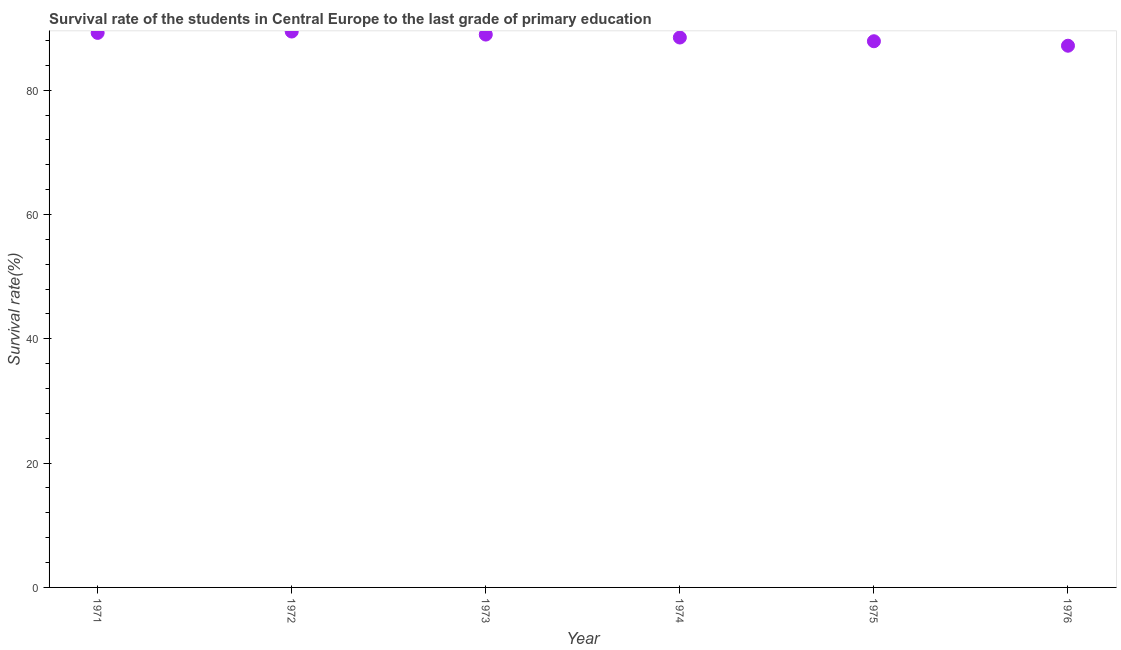What is the survival rate in primary education in 1971?
Provide a short and direct response. 89.22. Across all years, what is the maximum survival rate in primary education?
Ensure brevity in your answer.  89.44. Across all years, what is the minimum survival rate in primary education?
Ensure brevity in your answer.  87.16. In which year was the survival rate in primary education minimum?
Your answer should be compact. 1976. What is the sum of the survival rate in primary education?
Provide a short and direct response. 531.13. What is the difference between the survival rate in primary education in 1973 and 1974?
Provide a succinct answer. 0.47. What is the average survival rate in primary education per year?
Provide a short and direct response. 88.52. What is the median survival rate in primary education?
Your answer should be compact. 88.71. In how many years, is the survival rate in primary education greater than 8 %?
Provide a succinct answer. 6. Do a majority of the years between 1975 and 1973 (inclusive) have survival rate in primary education greater than 80 %?
Provide a short and direct response. No. What is the ratio of the survival rate in primary education in 1975 to that in 1976?
Give a very brief answer. 1.01. Is the difference between the survival rate in primary education in 1971 and 1973 greater than the difference between any two years?
Offer a terse response. No. What is the difference between the highest and the second highest survival rate in primary education?
Ensure brevity in your answer.  0.22. What is the difference between the highest and the lowest survival rate in primary education?
Provide a succinct answer. 2.28. In how many years, is the survival rate in primary education greater than the average survival rate in primary education taken over all years?
Give a very brief answer. 3. Does the survival rate in primary education monotonically increase over the years?
Offer a terse response. No. What is the difference between two consecutive major ticks on the Y-axis?
Give a very brief answer. 20. Are the values on the major ticks of Y-axis written in scientific E-notation?
Keep it short and to the point. No. Does the graph contain any zero values?
Give a very brief answer. No. What is the title of the graph?
Provide a succinct answer. Survival rate of the students in Central Europe to the last grade of primary education. What is the label or title of the Y-axis?
Make the answer very short. Survival rate(%). What is the Survival rate(%) in 1971?
Offer a very short reply. 89.22. What is the Survival rate(%) in 1972?
Provide a succinct answer. 89.44. What is the Survival rate(%) in 1973?
Make the answer very short. 88.95. What is the Survival rate(%) in 1974?
Your answer should be compact. 88.48. What is the Survival rate(%) in 1975?
Offer a terse response. 87.88. What is the Survival rate(%) in 1976?
Offer a very short reply. 87.16. What is the difference between the Survival rate(%) in 1971 and 1972?
Provide a short and direct response. -0.22. What is the difference between the Survival rate(%) in 1971 and 1973?
Ensure brevity in your answer.  0.27. What is the difference between the Survival rate(%) in 1971 and 1974?
Provide a short and direct response. 0.75. What is the difference between the Survival rate(%) in 1971 and 1975?
Keep it short and to the point. 1.34. What is the difference between the Survival rate(%) in 1971 and 1976?
Give a very brief answer. 2.07. What is the difference between the Survival rate(%) in 1972 and 1973?
Your answer should be very brief. 0.49. What is the difference between the Survival rate(%) in 1972 and 1974?
Offer a terse response. 0.96. What is the difference between the Survival rate(%) in 1972 and 1975?
Your answer should be very brief. 1.56. What is the difference between the Survival rate(%) in 1972 and 1976?
Your response must be concise. 2.28. What is the difference between the Survival rate(%) in 1973 and 1974?
Your answer should be very brief. 0.47. What is the difference between the Survival rate(%) in 1973 and 1975?
Provide a short and direct response. 1.07. What is the difference between the Survival rate(%) in 1973 and 1976?
Provide a short and direct response. 1.79. What is the difference between the Survival rate(%) in 1974 and 1975?
Offer a terse response. 0.6. What is the difference between the Survival rate(%) in 1974 and 1976?
Keep it short and to the point. 1.32. What is the difference between the Survival rate(%) in 1975 and 1976?
Provide a short and direct response. 0.72. What is the ratio of the Survival rate(%) in 1971 to that in 1972?
Give a very brief answer. 1. What is the ratio of the Survival rate(%) in 1971 to that in 1973?
Keep it short and to the point. 1. What is the ratio of the Survival rate(%) in 1971 to that in 1974?
Offer a terse response. 1.01. What is the ratio of the Survival rate(%) in 1971 to that in 1975?
Give a very brief answer. 1.01. What is the ratio of the Survival rate(%) in 1971 to that in 1976?
Provide a short and direct response. 1.02. What is the ratio of the Survival rate(%) in 1972 to that in 1973?
Provide a succinct answer. 1.01. What is the ratio of the Survival rate(%) in 1973 to that in 1976?
Offer a terse response. 1.02. What is the ratio of the Survival rate(%) in 1974 to that in 1975?
Give a very brief answer. 1.01. 